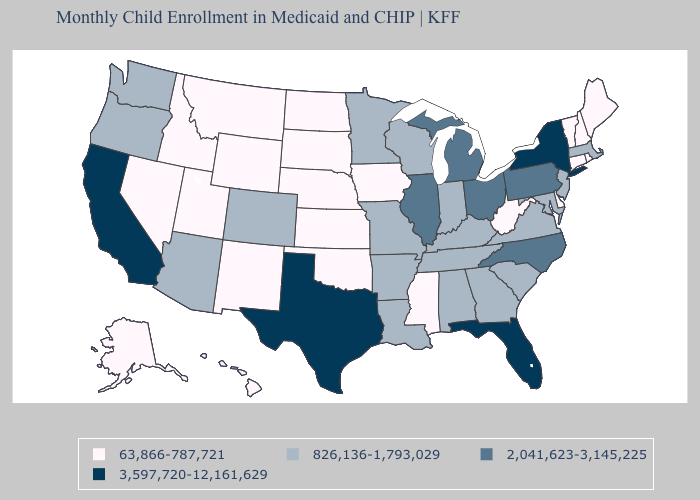What is the value of Hawaii?
Keep it brief. 63,866-787,721. Does California have the highest value in the USA?
Give a very brief answer. Yes. Name the states that have a value in the range 826,136-1,793,029?
Give a very brief answer. Alabama, Arizona, Arkansas, Colorado, Georgia, Indiana, Kentucky, Louisiana, Maryland, Massachusetts, Minnesota, Missouri, New Jersey, Oregon, South Carolina, Tennessee, Virginia, Washington, Wisconsin. Among the states that border Arkansas , does Mississippi have the lowest value?
Answer briefly. Yes. Among the states that border Nebraska , which have the highest value?
Quick response, please. Colorado, Missouri. Which states have the lowest value in the Northeast?
Be succinct. Connecticut, Maine, New Hampshire, Rhode Island, Vermont. How many symbols are there in the legend?
Write a very short answer. 4. Name the states that have a value in the range 3,597,720-12,161,629?
Give a very brief answer. California, Florida, New York, Texas. What is the lowest value in the USA?
Answer briefly. 63,866-787,721. Does New York have a lower value than New Jersey?
Be succinct. No. Name the states that have a value in the range 2,041,623-3,145,225?
Quick response, please. Illinois, Michigan, North Carolina, Ohio, Pennsylvania. Name the states that have a value in the range 2,041,623-3,145,225?
Write a very short answer. Illinois, Michigan, North Carolina, Ohio, Pennsylvania. Name the states that have a value in the range 2,041,623-3,145,225?
Answer briefly. Illinois, Michigan, North Carolina, Ohio, Pennsylvania. What is the lowest value in the USA?
Answer briefly. 63,866-787,721. Which states have the lowest value in the South?
Quick response, please. Delaware, Mississippi, Oklahoma, West Virginia. 